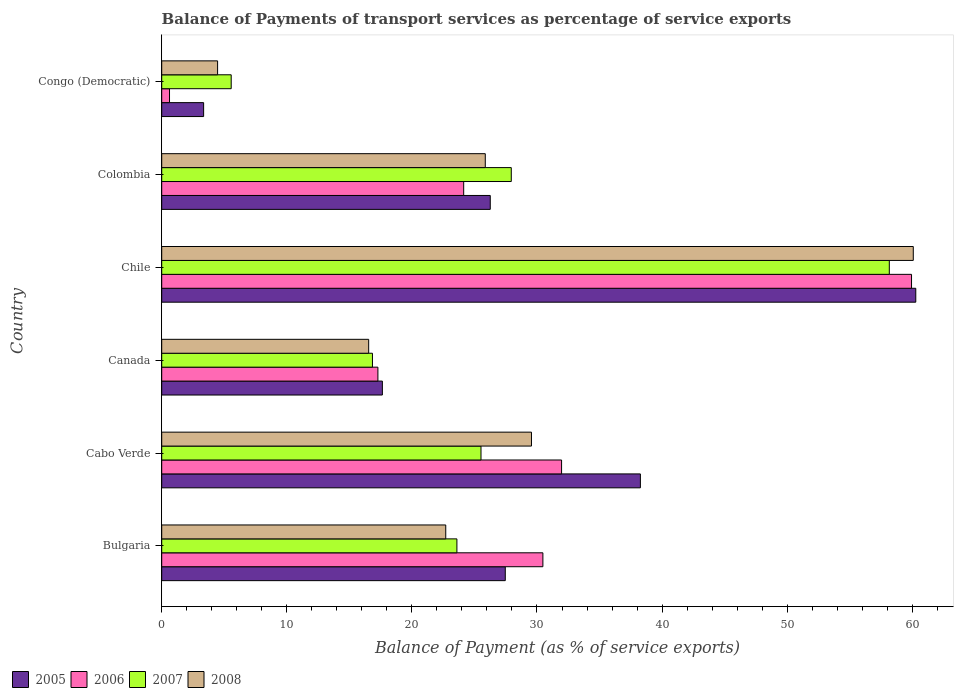How many different coloured bars are there?
Offer a terse response. 4. How many groups of bars are there?
Your answer should be compact. 6. How many bars are there on the 1st tick from the top?
Your answer should be compact. 4. How many bars are there on the 2nd tick from the bottom?
Make the answer very short. 4. What is the label of the 1st group of bars from the top?
Provide a short and direct response. Congo (Democratic). In how many cases, is the number of bars for a given country not equal to the number of legend labels?
Keep it short and to the point. 0. What is the balance of payments of transport services in 2007 in Colombia?
Provide a succinct answer. 27.95. Across all countries, what is the maximum balance of payments of transport services in 2005?
Give a very brief answer. 60.28. Across all countries, what is the minimum balance of payments of transport services in 2006?
Provide a succinct answer. 0.62. In which country was the balance of payments of transport services in 2005 minimum?
Keep it short and to the point. Congo (Democratic). What is the total balance of payments of transport services in 2007 in the graph?
Your response must be concise. 157.64. What is the difference between the balance of payments of transport services in 2006 in Cabo Verde and that in Congo (Democratic)?
Give a very brief answer. 31.34. What is the difference between the balance of payments of transport services in 2006 in Cabo Verde and the balance of payments of transport services in 2008 in Canada?
Provide a succinct answer. 15.42. What is the average balance of payments of transport services in 2008 per country?
Offer a terse response. 26.54. What is the difference between the balance of payments of transport services in 2008 and balance of payments of transport services in 2007 in Congo (Democratic)?
Ensure brevity in your answer.  -1.09. In how many countries, is the balance of payments of transport services in 2005 greater than 6 %?
Provide a short and direct response. 5. What is the ratio of the balance of payments of transport services in 2006 in Bulgaria to that in Canada?
Ensure brevity in your answer.  1.76. Is the difference between the balance of payments of transport services in 2008 in Chile and Colombia greater than the difference between the balance of payments of transport services in 2007 in Chile and Colombia?
Give a very brief answer. Yes. What is the difference between the highest and the second highest balance of payments of transport services in 2006?
Provide a short and direct response. 27.98. What is the difference between the highest and the lowest balance of payments of transport services in 2008?
Keep it short and to the point. 55.62. In how many countries, is the balance of payments of transport services in 2006 greater than the average balance of payments of transport services in 2006 taken over all countries?
Ensure brevity in your answer.  3. Is it the case that in every country, the sum of the balance of payments of transport services in 2006 and balance of payments of transport services in 2008 is greater than the sum of balance of payments of transport services in 2005 and balance of payments of transport services in 2007?
Give a very brief answer. No. What does the 4th bar from the bottom in Colombia represents?
Keep it short and to the point. 2008. How many bars are there?
Offer a terse response. 24. How many countries are there in the graph?
Ensure brevity in your answer.  6. Are the values on the major ticks of X-axis written in scientific E-notation?
Make the answer very short. No. Does the graph contain grids?
Provide a short and direct response. No. Where does the legend appear in the graph?
Your answer should be compact. Bottom left. How are the legend labels stacked?
Provide a succinct answer. Horizontal. What is the title of the graph?
Offer a terse response. Balance of Payments of transport services as percentage of service exports. Does "2000" appear as one of the legend labels in the graph?
Keep it short and to the point. No. What is the label or title of the X-axis?
Provide a short and direct response. Balance of Payment (as % of service exports). What is the label or title of the Y-axis?
Your answer should be very brief. Country. What is the Balance of Payment (as % of service exports) of 2005 in Bulgaria?
Ensure brevity in your answer.  27.47. What is the Balance of Payment (as % of service exports) in 2006 in Bulgaria?
Provide a succinct answer. 30.47. What is the Balance of Payment (as % of service exports) in 2007 in Bulgaria?
Provide a succinct answer. 23.6. What is the Balance of Payment (as % of service exports) of 2008 in Bulgaria?
Your answer should be compact. 22.71. What is the Balance of Payment (as % of service exports) in 2005 in Cabo Verde?
Make the answer very short. 38.27. What is the Balance of Payment (as % of service exports) in 2006 in Cabo Verde?
Offer a terse response. 31.97. What is the Balance of Payment (as % of service exports) of 2007 in Cabo Verde?
Make the answer very short. 25.53. What is the Balance of Payment (as % of service exports) of 2008 in Cabo Verde?
Give a very brief answer. 29.56. What is the Balance of Payment (as % of service exports) of 2005 in Canada?
Provide a succinct answer. 17.64. What is the Balance of Payment (as % of service exports) in 2006 in Canada?
Give a very brief answer. 17.28. What is the Balance of Payment (as % of service exports) in 2007 in Canada?
Offer a terse response. 16.85. What is the Balance of Payment (as % of service exports) in 2008 in Canada?
Give a very brief answer. 16.55. What is the Balance of Payment (as % of service exports) of 2005 in Chile?
Offer a terse response. 60.28. What is the Balance of Payment (as % of service exports) in 2006 in Chile?
Make the answer very short. 59.94. What is the Balance of Payment (as % of service exports) in 2007 in Chile?
Make the answer very short. 58.17. What is the Balance of Payment (as % of service exports) in 2008 in Chile?
Your answer should be very brief. 60.08. What is the Balance of Payment (as % of service exports) in 2005 in Colombia?
Provide a short and direct response. 26.27. What is the Balance of Payment (as % of service exports) in 2006 in Colombia?
Give a very brief answer. 24.14. What is the Balance of Payment (as % of service exports) of 2007 in Colombia?
Ensure brevity in your answer.  27.95. What is the Balance of Payment (as % of service exports) of 2008 in Colombia?
Your answer should be compact. 25.87. What is the Balance of Payment (as % of service exports) of 2005 in Congo (Democratic)?
Offer a terse response. 3.35. What is the Balance of Payment (as % of service exports) of 2006 in Congo (Democratic)?
Give a very brief answer. 0.62. What is the Balance of Payment (as % of service exports) in 2007 in Congo (Democratic)?
Give a very brief answer. 5.56. What is the Balance of Payment (as % of service exports) of 2008 in Congo (Democratic)?
Make the answer very short. 4.47. Across all countries, what is the maximum Balance of Payment (as % of service exports) in 2005?
Your response must be concise. 60.28. Across all countries, what is the maximum Balance of Payment (as % of service exports) of 2006?
Offer a terse response. 59.94. Across all countries, what is the maximum Balance of Payment (as % of service exports) of 2007?
Your answer should be compact. 58.17. Across all countries, what is the maximum Balance of Payment (as % of service exports) of 2008?
Your answer should be very brief. 60.08. Across all countries, what is the minimum Balance of Payment (as % of service exports) in 2005?
Keep it short and to the point. 3.35. Across all countries, what is the minimum Balance of Payment (as % of service exports) of 2006?
Give a very brief answer. 0.62. Across all countries, what is the minimum Balance of Payment (as % of service exports) in 2007?
Provide a succinct answer. 5.56. Across all countries, what is the minimum Balance of Payment (as % of service exports) of 2008?
Make the answer very short. 4.47. What is the total Balance of Payment (as % of service exports) in 2005 in the graph?
Ensure brevity in your answer.  173.27. What is the total Balance of Payment (as % of service exports) of 2006 in the graph?
Your answer should be compact. 164.43. What is the total Balance of Payment (as % of service exports) in 2007 in the graph?
Your answer should be compact. 157.64. What is the total Balance of Payment (as % of service exports) in 2008 in the graph?
Your answer should be compact. 159.23. What is the difference between the Balance of Payment (as % of service exports) in 2005 in Bulgaria and that in Cabo Verde?
Your answer should be compact. -10.8. What is the difference between the Balance of Payment (as % of service exports) in 2006 in Bulgaria and that in Cabo Verde?
Provide a short and direct response. -1.49. What is the difference between the Balance of Payment (as % of service exports) of 2007 in Bulgaria and that in Cabo Verde?
Your answer should be compact. -1.93. What is the difference between the Balance of Payment (as % of service exports) in 2008 in Bulgaria and that in Cabo Verde?
Your response must be concise. -6.85. What is the difference between the Balance of Payment (as % of service exports) in 2005 in Bulgaria and that in Canada?
Ensure brevity in your answer.  9.83. What is the difference between the Balance of Payment (as % of service exports) in 2006 in Bulgaria and that in Canada?
Provide a short and direct response. 13.19. What is the difference between the Balance of Payment (as % of service exports) in 2007 in Bulgaria and that in Canada?
Give a very brief answer. 6.75. What is the difference between the Balance of Payment (as % of service exports) of 2008 in Bulgaria and that in Canada?
Your response must be concise. 6.16. What is the difference between the Balance of Payment (as % of service exports) of 2005 in Bulgaria and that in Chile?
Offer a terse response. -32.82. What is the difference between the Balance of Payment (as % of service exports) in 2006 in Bulgaria and that in Chile?
Your response must be concise. -29.47. What is the difference between the Balance of Payment (as % of service exports) in 2007 in Bulgaria and that in Chile?
Offer a terse response. -34.57. What is the difference between the Balance of Payment (as % of service exports) in 2008 in Bulgaria and that in Chile?
Your response must be concise. -37.38. What is the difference between the Balance of Payment (as % of service exports) in 2005 in Bulgaria and that in Colombia?
Your answer should be very brief. 1.2. What is the difference between the Balance of Payment (as % of service exports) of 2006 in Bulgaria and that in Colombia?
Your response must be concise. 6.33. What is the difference between the Balance of Payment (as % of service exports) in 2007 in Bulgaria and that in Colombia?
Your answer should be very brief. -4.35. What is the difference between the Balance of Payment (as % of service exports) in 2008 in Bulgaria and that in Colombia?
Offer a terse response. -3.16. What is the difference between the Balance of Payment (as % of service exports) in 2005 in Bulgaria and that in Congo (Democratic)?
Your response must be concise. 24.12. What is the difference between the Balance of Payment (as % of service exports) in 2006 in Bulgaria and that in Congo (Democratic)?
Your answer should be compact. 29.85. What is the difference between the Balance of Payment (as % of service exports) of 2007 in Bulgaria and that in Congo (Democratic)?
Ensure brevity in your answer.  18.04. What is the difference between the Balance of Payment (as % of service exports) in 2008 in Bulgaria and that in Congo (Democratic)?
Give a very brief answer. 18.24. What is the difference between the Balance of Payment (as % of service exports) in 2005 in Cabo Verde and that in Canada?
Keep it short and to the point. 20.63. What is the difference between the Balance of Payment (as % of service exports) of 2006 in Cabo Verde and that in Canada?
Keep it short and to the point. 14.68. What is the difference between the Balance of Payment (as % of service exports) of 2007 in Cabo Verde and that in Canada?
Keep it short and to the point. 8.68. What is the difference between the Balance of Payment (as % of service exports) of 2008 in Cabo Verde and that in Canada?
Provide a short and direct response. 13.01. What is the difference between the Balance of Payment (as % of service exports) of 2005 in Cabo Verde and that in Chile?
Provide a succinct answer. -22.02. What is the difference between the Balance of Payment (as % of service exports) of 2006 in Cabo Verde and that in Chile?
Give a very brief answer. -27.98. What is the difference between the Balance of Payment (as % of service exports) of 2007 in Cabo Verde and that in Chile?
Your answer should be compact. -32.64. What is the difference between the Balance of Payment (as % of service exports) in 2008 in Cabo Verde and that in Chile?
Offer a terse response. -30.52. What is the difference between the Balance of Payment (as % of service exports) in 2005 in Cabo Verde and that in Colombia?
Ensure brevity in your answer.  12. What is the difference between the Balance of Payment (as % of service exports) in 2006 in Cabo Verde and that in Colombia?
Give a very brief answer. 7.82. What is the difference between the Balance of Payment (as % of service exports) of 2007 in Cabo Verde and that in Colombia?
Your answer should be compact. -2.42. What is the difference between the Balance of Payment (as % of service exports) of 2008 in Cabo Verde and that in Colombia?
Provide a succinct answer. 3.69. What is the difference between the Balance of Payment (as % of service exports) of 2005 in Cabo Verde and that in Congo (Democratic)?
Provide a short and direct response. 34.92. What is the difference between the Balance of Payment (as % of service exports) of 2006 in Cabo Verde and that in Congo (Democratic)?
Your response must be concise. 31.34. What is the difference between the Balance of Payment (as % of service exports) in 2007 in Cabo Verde and that in Congo (Democratic)?
Provide a succinct answer. 19.97. What is the difference between the Balance of Payment (as % of service exports) in 2008 in Cabo Verde and that in Congo (Democratic)?
Your response must be concise. 25.09. What is the difference between the Balance of Payment (as % of service exports) in 2005 in Canada and that in Chile?
Provide a short and direct response. -42.64. What is the difference between the Balance of Payment (as % of service exports) of 2006 in Canada and that in Chile?
Provide a succinct answer. -42.66. What is the difference between the Balance of Payment (as % of service exports) in 2007 in Canada and that in Chile?
Offer a very short reply. -41.32. What is the difference between the Balance of Payment (as % of service exports) of 2008 in Canada and that in Chile?
Offer a very short reply. -43.54. What is the difference between the Balance of Payment (as % of service exports) of 2005 in Canada and that in Colombia?
Your answer should be compact. -8.63. What is the difference between the Balance of Payment (as % of service exports) of 2006 in Canada and that in Colombia?
Keep it short and to the point. -6.86. What is the difference between the Balance of Payment (as % of service exports) in 2007 in Canada and that in Colombia?
Offer a terse response. -11.1. What is the difference between the Balance of Payment (as % of service exports) of 2008 in Canada and that in Colombia?
Your response must be concise. -9.32. What is the difference between the Balance of Payment (as % of service exports) in 2005 in Canada and that in Congo (Democratic)?
Keep it short and to the point. 14.29. What is the difference between the Balance of Payment (as % of service exports) in 2006 in Canada and that in Congo (Democratic)?
Offer a terse response. 16.66. What is the difference between the Balance of Payment (as % of service exports) in 2007 in Canada and that in Congo (Democratic)?
Ensure brevity in your answer.  11.29. What is the difference between the Balance of Payment (as % of service exports) of 2008 in Canada and that in Congo (Democratic)?
Give a very brief answer. 12.08. What is the difference between the Balance of Payment (as % of service exports) in 2005 in Chile and that in Colombia?
Offer a terse response. 34.02. What is the difference between the Balance of Payment (as % of service exports) of 2006 in Chile and that in Colombia?
Make the answer very short. 35.8. What is the difference between the Balance of Payment (as % of service exports) in 2007 in Chile and that in Colombia?
Offer a very short reply. 30.22. What is the difference between the Balance of Payment (as % of service exports) in 2008 in Chile and that in Colombia?
Give a very brief answer. 34.22. What is the difference between the Balance of Payment (as % of service exports) of 2005 in Chile and that in Congo (Democratic)?
Your answer should be very brief. 56.93. What is the difference between the Balance of Payment (as % of service exports) in 2006 in Chile and that in Congo (Democratic)?
Make the answer very short. 59.32. What is the difference between the Balance of Payment (as % of service exports) of 2007 in Chile and that in Congo (Democratic)?
Give a very brief answer. 52.61. What is the difference between the Balance of Payment (as % of service exports) in 2008 in Chile and that in Congo (Democratic)?
Offer a very short reply. 55.62. What is the difference between the Balance of Payment (as % of service exports) in 2005 in Colombia and that in Congo (Democratic)?
Your answer should be very brief. 22.91. What is the difference between the Balance of Payment (as % of service exports) in 2006 in Colombia and that in Congo (Democratic)?
Keep it short and to the point. 23.52. What is the difference between the Balance of Payment (as % of service exports) of 2007 in Colombia and that in Congo (Democratic)?
Offer a terse response. 22.39. What is the difference between the Balance of Payment (as % of service exports) of 2008 in Colombia and that in Congo (Democratic)?
Keep it short and to the point. 21.4. What is the difference between the Balance of Payment (as % of service exports) of 2005 in Bulgaria and the Balance of Payment (as % of service exports) of 2006 in Cabo Verde?
Provide a short and direct response. -4.5. What is the difference between the Balance of Payment (as % of service exports) of 2005 in Bulgaria and the Balance of Payment (as % of service exports) of 2007 in Cabo Verde?
Your response must be concise. 1.94. What is the difference between the Balance of Payment (as % of service exports) in 2005 in Bulgaria and the Balance of Payment (as % of service exports) in 2008 in Cabo Verde?
Your answer should be compact. -2.09. What is the difference between the Balance of Payment (as % of service exports) in 2006 in Bulgaria and the Balance of Payment (as % of service exports) in 2007 in Cabo Verde?
Your response must be concise. 4.95. What is the difference between the Balance of Payment (as % of service exports) of 2006 in Bulgaria and the Balance of Payment (as % of service exports) of 2008 in Cabo Verde?
Keep it short and to the point. 0.91. What is the difference between the Balance of Payment (as % of service exports) of 2007 in Bulgaria and the Balance of Payment (as % of service exports) of 2008 in Cabo Verde?
Provide a short and direct response. -5.96. What is the difference between the Balance of Payment (as % of service exports) in 2005 in Bulgaria and the Balance of Payment (as % of service exports) in 2006 in Canada?
Your response must be concise. 10.18. What is the difference between the Balance of Payment (as % of service exports) in 2005 in Bulgaria and the Balance of Payment (as % of service exports) in 2007 in Canada?
Your answer should be compact. 10.62. What is the difference between the Balance of Payment (as % of service exports) of 2005 in Bulgaria and the Balance of Payment (as % of service exports) of 2008 in Canada?
Make the answer very short. 10.92. What is the difference between the Balance of Payment (as % of service exports) in 2006 in Bulgaria and the Balance of Payment (as % of service exports) in 2007 in Canada?
Your response must be concise. 13.63. What is the difference between the Balance of Payment (as % of service exports) in 2006 in Bulgaria and the Balance of Payment (as % of service exports) in 2008 in Canada?
Offer a very short reply. 13.93. What is the difference between the Balance of Payment (as % of service exports) in 2007 in Bulgaria and the Balance of Payment (as % of service exports) in 2008 in Canada?
Your answer should be very brief. 7.05. What is the difference between the Balance of Payment (as % of service exports) of 2005 in Bulgaria and the Balance of Payment (as % of service exports) of 2006 in Chile?
Provide a short and direct response. -32.48. What is the difference between the Balance of Payment (as % of service exports) in 2005 in Bulgaria and the Balance of Payment (as % of service exports) in 2007 in Chile?
Offer a very short reply. -30.7. What is the difference between the Balance of Payment (as % of service exports) of 2005 in Bulgaria and the Balance of Payment (as % of service exports) of 2008 in Chile?
Your answer should be compact. -32.62. What is the difference between the Balance of Payment (as % of service exports) in 2006 in Bulgaria and the Balance of Payment (as % of service exports) in 2007 in Chile?
Make the answer very short. -27.69. What is the difference between the Balance of Payment (as % of service exports) of 2006 in Bulgaria and the Balance of Payment (as % of service exports) of 2008 in Chile?
Keep it short and to the point. -29.61. What is the difference between the Balance of Payment (as % of service exports) in 2007 in Bulgaria and the Balance of Payment (as % of service exports) in 2008 in Chile?
Your answer should be very brief. -36.48. What is the difference between the Balance of Payment (as % of service exports) of 2005 in Bulgaria and the Balance of Payment (as % of service exports) of 2006 in Colombia?
Keep it short and to the point. 3.33. What is the difference between the Balance of Payment (as % of service exports) of 2005 in Bulgaria and the Balance of Payment (as % of service exports) of 2007 in Colombia?
Offer a terse response. -0.48. What is the difference between the Balance of Payment (as % of service exports) in 2005 in Bulgaria and the Balance of Payment (as % of service exports) in 2008 in Colombia?
Your response must be concise. 1.6. What is the difference between the Balance of Payment (as % of service exports) in 2006 in Bulgaria and the Balance of Payment (as % of service exports) in 2007 in Colombia?
Make the answer very short. 2.53. What is the difference between the Balance of Payment (as % of service exports) of 2006 in Bulgaria and the Balance of Payment (as % of service exports) of 2008 in Colombia?
Your response must be concise. 4.61. What is the difference between the Balance of Payment (as % of service exports) of 2007 in Bulgaria and the Balance of Payment (as % of service exports) of 2008 in Colombia?
Offer a terse response. -2.27. What is the difference between the Balance of Payment (as % of service exports) in 2005 in Bulgaria and the Balance of Payment (as % of service exports) in 2006 in Congo (Democratic)?
Keep it short and to the point. 26.84. What is the difference between the Balance of Payment (as % of service exports) in 2005 in Bulgaria and the Balance of Payment (as % of service exports) in 2007 in Congo (Democratic)?
Your response must be concise. 21.91. What is the difference between the Balance of Payment (as % of service exports) in 2005 in Bulgaria and the Balance of Payment (as % of service exports) in 2008 in Congo (Democratic)?
Make the answer very short. 23. What is the difference between the Balance of Payment (as % of service exports) of 2006 in Bulgaria and the Balance of Payment (as % of service exports) of 2007 in Congo (Democratic)?
Give a very brief answer. 24.92. What is the difference between the Balance of Payment (as % of service exports) of 2006 in Bulgaria and the Balance of Payment (as % of service exports) of 2008 in Congo (Democratic)?
Ensure brevity in your answer.  26.01. What is the difference between the Balance of Payment (as % of service exports) in 2007 in Bulgaria and the Balance of Payment (as % of service exports) in 2008 in Congo (Democratic)?
Provide a succinct answer. 19.13. What is the difference between the Balance of Payment (as % of service exports) of 2005 in Cabo Verde and the Balance of Payment (as % of service exports) of 2006 in Canada?
Offer a very short reply. 20.98. What is the difference between the Balance of Payment (as % of service exports) in 2005 in Cabo Verde and the Balance of Payment (as % of service exports) in 2007 in Canada?
Ensure brevity in your answer.  21.42. What is the difference between the Balance of Payment (as % of service exports) of 2005 in Cabo Verde and the Balance of Payment (as % of service exports) of 2008 in Canada?
Make the answer very short. 21.72. What is the difference between the Balance of Payment (as % of service exports) in 2006 in Cabo Verde and the Balance of Payment (as % of service exports) in 2007 in Canada?
Keep it short and to the point. 15.12. What is the difference between the Balance of Payment (as % of service exports) of 2006 in Cabo Verde and the Balance of Payment (as % of service exports) of 2008 in Canada?
Your response must be concise. 15.42. What is the difference between the Balance of Payment (as % of service exports) in 2007 in Cabo Verde and the Balance of Payment (as % of service exports) in 2008 in Canada?
Give a very brief answer. 8.98. What is the difference between the Balance of Payment (as % of service exports) in 2005 in Cabo Verde and the Balance of Payment (as % of service exports) in 2006 in Chile?
Make the answer very short. -21.68. What is the difference between the Balance of Payment (as % of service exports) in 2005 in Cabo Verde and the Balance of Payment (as % of service exports) in 2007 in Chile?
Make the answer very short. -19.9. What is the difference between the Balance of Payment (as % of service exports) in 2005 in Cabo Verde and the Balance of Payment (as % of service exports) in 2008 in Chile?
Provide a succinct answer. -21.82. What is the difference between the Balance of Payment (as % of service exports) in 2006 in Cabo Verde and the Balance of Payment (as % of service exports) in 2007 in Chile?
Your answer should be compact. -26.2. What is the difference between the Balance of Payment (as % of service exports) of 2006 in Cabo Verde and the Balance of Payment (as % of service exports) of 2008 in Chile?
Give a very brief answer. -28.12. What is the difference between the Balance of Payment (as % of service exports) of 2007 in Cabo Verde and the Balance of Payment (as % of service exports) of 2008 in Chile?
Provide a short and direct response. -34.56. What is the difference between the Balance of Payment (as % of service exports) of 2005 in Cabo Verde and the Balance of Payment (as % of service exports) of 2006 in Colombia?
Provide a short and direct response. 14.13. What is the difference between the Balance of Payment (as % of service exports) in 2005 in Cabo Verde and the Balance of Payment (as % of service exports) in 2007 in Colombia?
Your response must be concise. 10.32. What is the difference between the Balance of Payment (as % of service exports) of 2005 in Cabo Verde and the Balance of Payment (as % of service exports) of 2008 in Colombia?
Offer a very short reply. 12.4. What is the difference between the Balance of Payment (as % of service exports) in 2006 in Cabo Verde and the Balance of Payment (as % of service exports) in 2007 in Colombia?
Provide a succinct answer. 4.02. What is the difference between the Balance of Payment (as % of service exports) of 2006 in Cabo Verde and the Balance of Payment (as % of service exports) of 2008 in Colombia?
Keep it short and to the point. 6.1. What is the difference between the Balance of Payment (as % of service exports) in 2007 in Cabo Verde and the Balance of Payment (as % of service exports) in 2008 in Colombia?
Your answer should be very brief. -0.34. What is the difference between the Balance of Payment (as % of service exports) of 2005 in Cabo Verde and the Balance of Payment (as % of service exports) of 2006 in Congo (Democratic)?
Keep it short and to the point. 37.64. What is the difference between the Balance of Payment (as % of service exports) of 2005 in Cabo Verde and the Balance of Payment (as % of service exports) of 2007 in Congo (Democratic)?
Your answer should be very brief. 32.71. What is the difference between the Balance of Payment (as % of service exports) in 2005 in Cabo Verde and the Balance of Payment (as % of service exports) in 2008 in Congo (Democratic)?
Ensure brevity in your answer.  33.8. What is the difference between the Balance of Payment (as % of service exports) of 2006 in Cabo Verde and the Balance of Payment (as % of service exports) of 2007 in Congo (Democratic)?
Your answer should be compact. 26.41. What is the difference between the Balance of Payment (as % of service exports) of 2006 in Cabo Verde and the Balance of Payment (as % of service exports) of 2008 in Congo (Democratic)?
Offer a terse response. 27.5. What is the difference between the Balance of Payment (as % of service exports) of 2007 in Cabo Verde and the Balance of Payment (as % of service exports) of 2008 in Congo (Democratic)?
Ensure brevity in your answer.  21.06. What is the difference between the Balance of Payment (as % of service exports) in 2005 in Canada and the Balance of Payment (as % of service exports) in 2006 in Chile?
Give a very brief answer. -42.3. What is the difference between the Balance of Payment (as % of service exports) of 2005 in Canada and the Balance of Payment (as % of service exports) of 2007 in Chile?
Make the answer very short. -40.53. What is the difference between the Balance of Payment (as % of service exports) of 2005 in Canada and the Balance of Payment (as % of service exports) of 2008 in Chile?
Keep it short and to the point. -42.44. What is the difference between the Balance of Payment (as % of service exports) in 2006 in Canada and the Balance of Payment (as % of service exports) in 2007 in Chile?
Offer a very short reply. -40.88. What is the difference between the Balance of Payment (as % of service exports) in 2006 in Canada and the Balance of Payment (as % of service exports) in 2008 in Chile?
Offer a terse response. -42.8. What is the difference between the Balance of Payment (as % of service exports) of 2007 in Canada and the Balance of Payment (as % of service exports) of 2008 in Chile?
Offer a terse response. -43.24. What is the difference between the Balance of Payment (as % of service exports) of 2005 in Canada and the Balance of Payment (as % of service exports) of 2006 in Colombia?
Ensure brevity in your answer.  -6.5. What is the difference between the Balance of Payment (as % of service exports) of 2005 in Canada and the Balance of Payment (as % of service exports) of 2007 in Colombia?
Ensure brevity in your answer.  -10.31. What is the difference between the Balance of Payment (as % of service exports) in 2005 in Canada and the Balance of Payment (as % of service exports) in 2008 in Colombia?
Offer a very short reply. -8.23. What is the difference between the Balance of Payment (as % of service exports) in 2006 in Canada and the Balance of Payment (as % of service exports) in 2007 in Colombia?
Your response must be concise. -10.66. What is the difference between the Balance of Payment (as % of service exports) in 2006 in Canada and the Balance of Payment (as % of service exports) in 2008 in Colombia?
Make the answer very short. -8.58. What is the difference between the Balance of Payment (as % of service exports) in 2007 in Canada and the Balance of Payment (as % of service exports) in 2008 in Colombia?
Provide a succinct answer. -9.02. What is the difference between the Balance of Payment (as % of service exports) in 2005 in Canada and the Balance of Payment (as % of service exports) in 2006 in Congo (Democratic)?
Your response must be concise. 17.02. What is the difference between the Balance of Payment (as % of service exports) in 2005 in Canada and the Balance of Payment (as % of service exports) in 2007 in Congo (Democratic)?
Offer a very short reply. 12.08. What is the difference between the Balance of Payment (as % of service exports) of 2005 in Canada and the Balance of Payment (as % of service exports) of 2008 in Congo (Democratic)?
Offer a very short reply. 13.17. What is the difference between the Balance of Payment (as % of service exports) in 2006 in Canada and the Balance of Payment (as % of service exports) in 2007 in Congo (Democratic)?
Give a very brief answer. 11.73. What is the difference between the Balance of Payment (as % of service exports) of 2006 in Canada and the Balance of Payment (as % of service exports) of 2008 in Congo (Democratic)?
Give a very brief answer. 12.82. What is the difference between the Balance of Payment (as % of service exports) in 2007 in Canada and the Balance of Payment (as % of service exports) in 2008 in Congo (Democratic)?
Offer a very short reply. 12.38. What is the difference between the Balance of Payment (as % of service exports) of 2005 in Chile and the Balance of Payment (as % of service exports) of 2006 in Colombia?
Give a very brief answer. 36.14. What is the difference between the Balance of Payment (as % of service exports) in 2005 in Chile and the Balance of Payment (as % of service exports) in 2007 in Colombia?
Ensure brevity in your answer.  32.34. What is the difference between the Balance of Payment (as % of service exports) of 2005 in Chile and the Balance of Payment (as % of service exports) of 2008 in Colombia?
Your answer should be very brief. 34.42. What is the difference between the Balance of Payment (as % of service exports) in 2006 in Chile and the Balance of Payment (as % of service exports) in 2007 in Colombia?
Keep it short and to the point. 32. What is the difference between the Balance of Payment (as % of service exports) in 2006 in Chile and the Balance of Payment (as % of service exports) in 2008 in Colombia?
Provide a succinct answer. 34.08. What is the difference between the Balance of Payment (as % of service exports) in 2007 in Chile and the Balance of Payment (as % of service exports) in 2008 in Colombia?
Provide a succinct answer. 32.3. What is the difference between the Balance of Payment (as % of service exports) in 2005 in Chile and the Balance of Payment (as % of service exports) in 2006 in Congo (Democratic)?
Keep it short and to the point. 59.66. What is the difference between the Balance of Payment (as % of service exports) of 2005 in Chile and the Balance of Payment (as % of service exports) of 2007 in Congo (Democratic)?
Provide a succinct answer. 54.73. What is the difference between the Balance of Payment (as % of service exports) of 2005 in Chile and the Balance of Payment (as % of service exports) of 2008 in Congo (Democratic)?
Offer a very short reply. 55.82. What is the difference between the Balance of Payment (as % of service exports) of 2006 in Chile and the Balance of Payment (as % of service exports) of 2007 in Congo (Democratic)?
Your answer should be compact. 54.39. What is the difference between the Balance of Payment (as % of service exports) of 2006 in Chile and the Balance of Payment (as % of service exports) of 2008 in Congo (Democratic)?
Make the answer very short. 55.48. What is the difference between the Balance of Payment (as % of service exports) of 2007 in Chile and the Balance of Payment (as % of service exports) of 2008 in Congo (Democratic)?
Provide a short and direct response. 53.7. What is the difference between the Balance of Payment (as % of service exports) in 2005 in Colombia and the Balance of Payment (as % of service exports) in 2006 in Congo (Democratic)?
Make the answer very short. 25.64. What is the difference between the Balance of Payment (as % of service exports) in 2005 in Colombia and the Balance of Payment (as % of service exports) in 2007 in Congo (Democratic)?
Give a very brief answer. 20.71. What is the difference between the Balance of Payment (as % of service exports) of 2005 in Colombia and the Balance of Payment (as % of service exports) of 2008 in Congo (Democratic)?
Give a very brief answer. 21.8. What is the difference between the Balance of Payment (as % of service exports) of 2006 in Colombia and the Balance of Payment (as % of service exports) of 2007 in Congo (Democratic)?
Provide a succinct answer. 18.59. What is the difference between the Balance of Payment (as % of service exports) of 2006 in Colombia and the Balance of Payment (as % of service exports) of 2008 in Congo (Democratic)?
Provide a short and direct response. 19.67. What is the difference between the Balance of Payment (as % of service exports) of 2007 in Colombia and the Balance of Payment (as % of service exports) of 2008 in Congo (Democratic)?
Your response must be concise. 23.48. What is the average Balance of Payment (as % of service exports) of 2005 per country?
Ensure brevity in your answer.  28.88. What is the average Balance of Payment (as % of service exports) of 2006 per country?
Your response must be concise. 27.41. What is the average Balance of Payment (as % of service exports) of 2007 per country?
Ensure brevity in your answer.  26.27. What is the average Balance of Payment (as % of service exports) of 2008 per country?
Ensure brevity in your answer.  26.54. What is the difference between the Balance of Payment (as % of service exports) in 2005 and Balance of Payment (as % of service exports) in 2006 in Bulgaria?
Your answer should be compact. -3.01. What is the difference between the Balance of Payment (as % of service exports) of 2005 and Balance of Payment (as % of service exports) of 2007 in Bulgaria?
Ensure brevity in your answer.  3.87. What is the difference between the Balance of Payment (as % of service exports) of 2005 and Balance of Payment (as % of service exports) of 2008 in Bulgaria?
Provide a succinct answer. 4.76. What is the difference between the Balance of Payment (as % of service exports) of 2006 and Balance of Payment (as % of service exports) of 2007 in Bulgaria?
Make the answer very short. 6.87. What is the difference between the Balance of Payment (as % of service exports) of 2006 and Balance of Payment (as % of service exports) of 2008 in Bulgaria?
Give a very brief answer. 7.77. What is the difference between the Balance of Payment (as % of service exports) in 2007 and Balance of Payment (as % of service exports) in 2008 in Bulgaria?
Provide a short and direct response. 0.89. What is the difference between the Balance of Payment (as % of service exports) of 2005 and Balance of Payment (as % of service exports) of 2006 in Cabo Verde?
Make the answer very short. 6.3. What is the difference between the Balance of Payment (as % of service exports) of 2005 and Balance of Payment (as % of service exports) of 2007 in Cabo Verde?
Your answer should be very brief. 12.74. What is the difference between the Balance of Payment (as % of service exports) of 2005 and Balance of Payment (as % of service exports) of 2008 in Cabo Verde?
Provide a succinct answer. 8.71. What is the difference between the Balance of Payment (as % of service exports) in 2006 and Balance of Payment (as % of service exports) in 2007 in Cabo Verde?
Your response must be concise. 6.44. What is the difference between the Balance of Payment (as % of service exports) of 2006 and Balance of Payment (as % of service exports) of 2008 in Cabo Verde?
Your answer should be very brief. 2.41. What is the difference between the Balance of Payment (as % of service exports) of 2007 and Balance of Payment (as % of service exports) of 2008 in Cabo Verde?
Your answer should be very brief. -4.03. What is the difference between the Balance of Payment (as % of service exports) in 2005 and Balance of Payment (as % of service exports) in 2006 in Canada?
Offer a terse response. 0.36. What is the difference between the Balance of Payment (as % of service exports) in 2005 and Balance of Payment (as % of service exports) in 2007 in Canada?
Offer a very short reply. 0.79. What is the difference between the Balance of Payment (as % of service exports) of 2005 and Balance of Payment (as % of service exports) of 2008 in Canada?
Your answer should be very brief. 1.09. What is the difference between the Balance of Payment (as % of service exports) of 2006 and Balance of Payment (as % of service exports) of 2007 in Canada?
Offer a terse response. 0.44. What is the difference between the Balance of Payment (as % of service exports) of 2006 and Balance of Payment (as % of service exports) of 2008 in Canada?
Make the answer very short. 0.74. What is the difference between the Balance of Payment (as % of service exports) of 2007 and Balance of Payment (as % of service exports) of 2008 in Canada?
Your answer should be very brief. 0.3. What is the difference between the Balance of Payment (as % of service exports) of 2005 and Balance of Payment (as % of service exports) of 2006 in Chile?
Give a very brief answer. 0.34. What is the difference between the Balance of Payment (as % of service exports) in 2005 and Balance of Payment (as % of service exports) in 2007 in Chile?
Your response must be concise. 2.12. What is the difference between the Balance of Payment (as % of service exports) in 2005 and Balance of Payment (as % of service exports) in 2008 in Chile?
Ensure brevity in your answer.  0.2. What is the difference between the Balance of Payment (as % of service exports) in 2006 and Balance of Payment (as % of service exports) in 2007 in Chile?
Make the answer very short. 1.78. What is the difference between the Balance of Payment (as % of service exports) of 2006 and Balance of Payment (as % of service exports) of 2008 in Chile?
Your answer should be very brief. -0.14. What is the difference between the Balance of Payment (as % of service exports) of 2007 and Balance of Payment (as % of service exports) of 2008 in Chile?
Your answer should be very brief. -1.92. What is the difference between the Balance of Payment (as % of service exports) of 2005 and Balance of Payment (as % of service exports) of 2006 in Colombia?
Ensure brevity in your answer.  2.12. What is the difference between the Balance of Payment (as % of service exports) of 2005 and Balance of Payment (as % of service exports) of 2007 in Colombia?
Offer a very short reply. -1.68. What is the difference between the Balance of Payment (as % of service exports) of 2005 and Balance of Payment (as % of service exports) of 2008 in Colombia?
Offer a terse response. 0.4. What is the difference between the Balance of Payment (as % of service exports) in 2006 and Balance of Payment (as % of service exports) in 2007 in Colombia?
Provide a succinct answer. -3.8. What is the difference between the Balance of Payment (as % of service exports) in 2006 and Balance of Payment (as % of service exports) in 2008 in Colombia?
Your answer should be very brief. -1.73. What is the difference between the Balance of Payment (as % of service exports) of 2007 and Balance of Payment (as % of service exports) of 2008 in Colombia?
Offer a terse response. 2.08. What is the difference between the Balance of Payment (as % of service exports) in 2005 and Balance of Payment (as % of service exports) in 2006 in Congo (Democratic)?
Offer a terse response. 2.73. What is the difference between the Balance of Payment (as % of service exports) in 2005 and Balance of Payment (as % of service exports) in 2007 in Congo (Democratic)?
Your answer should be very brief. -2.2. What is the difference between the Balance of Payment (as % of service exports) of 2005 and Balance of Payment (as % of service exports) of 2008 in Congo (Democratic)?
Offer a terse response. -1.12. What is the difference between the Balance of Payment (as % of service exports) of 2006 and Balance of Payment (as % of service exports) of 2007 in Congo (Democratic)?
Your answer should be very brief. -4.93. What is the difference between the Balance of Payment (as % of service exports) of 2006 and Balance of Payment (as % of service exports) of 2008 in Congo (Democratic)?
Your response must be concise. -3.84. What is the difference between the Balance of Payment (as % of service exports) in 2007 and Balance of Payment (as % of service exports) in 2008 in Congo (Democratic)?
Your answer should be very brief. 1.09. What is the ratio of the Balance of Payment (as % of service exports) in 2005 in Bulgaria to that in Cabo Verde?
Keep it short and to the point. 0.72. What is the ratio of the Balance of Payment (as % of service exports) of 2006 in Bulgaria to that in Cabo Verde?
Your response must be concise. 0.95. What is the ratio of the Balance of Payment (as % of service exports) of 2007 in Bulgaria to that in Cabo Verde?
Offer a very short reply. 0.92. What is the ratio of the Balance of Payment (as % of service exports) in 2008 in Bulgaria to that in Cabo Verde?
Ensure brevity in your answer.  0.77. What is the ratio of the Balance of Payment (as % of service exports) in 2005 in Bulgaria to that in Canada?
Provide a short and direct response. 1.56. What is the ratio of the Balance of Payment (as % of service exports) in 2006 in Bulgaria to that in Canada?
Keep it short and to the point. 1.76. What is the ratio of the Balance of Payment (as % of service exports) in 2007 in Bulgaria to that in Canada?
Provide a succinct answer. 1.4. What is the ratio of the Balance of Payment (as % of service exports) in 2008 in Bulgaria to that in Canada?
Offer a terse response. 1.37. What is the ratio of the Balance of Payment (as % of service exports) of 2005 in Bulgaria to that in Chile?
Make the answer very short. 0.46. What is the ratio of the Balance of Payment (as % of service exports) of 2006 in Bulgaria to that in Chile?
Offer a very short reply. 0.51. What is the ratio of the Balance of Payment (as % of service exports) in 2007 in Bulgaria to that in Chile?
Your answer should be compact. 0.41. What is the ratio of the Balance of Payment (as % of service exports) in 2008 in Bulgaria to that in Chile?
Your response must be concise. 0.38. What is the ratio of the Balance of Payment (as % of service exports) in 2005 in Bulgaria to that in Colombia?
Your answer should be very brief. 1.05. What is the ratio of the Balance of Payment (as % of service exports) of 2006 in Bulgaria to that in Colombia?
Provide a short and direct response. 1.26. What is the ratio of the Balance of Payment (as % of service exports) of 2007 in Bulgaria to that in Colombia?
Offer a very short reply. 0.84. What is the ratio of the Balance of Payment (as % of service exports) of 2008 in Bulgaria to that in Colombia?
Provide a short and direct response. 0.88. What is the ratio of the Balance of Payment (as % of service exports) of 2005 in Bulgaria to that in Congo (Democratic)?
Provide a short and direct response. 8.2. What is the ratio of the Balance of Payment (as % of service exports) of 2006 in Bulgaria to that in Congo (Democratic)?
Offer a terse response. 48.86. What is the ratio of the Balance of Payment (as % of service exports) in 2007 in Bulgaria to that in Congo (Democratic)?
Provide a succinct answer. 4.25. What is the ratio of the Balance of Payment (as % of service exports) in 2008 in Bulgaria to that in Congo (Democratic)?
Keep it short and to the point. 5.08. What is the ratio of the Balance of Payment (as % of service exports) in 2005 in Cabo Verde to that in Canada?
Your answer should be very brief. 2.17. What is the ratio of the Balance of Payment (as % of service exports) in 2006 in Cabo Verde to that in Canada?
Your response must be concise. 1.85. What is the ratio of the Balance of Payment (as % of service exports) in 2007 in Cabo Verde to that in Canada?
Keep it short and to the point. 1.52. What is the ratio of the Balance of Payment (as % of service exports) in 2008 in Cabo Verde to that in Canada?
Provide a succinct answer. 1.79. What is the ratio of the Balance of Payment (as % of service exports) of 2005 in Cabo Verde to that in Chile?
Provide a short and direct response. 0.63. What is the ratio of the Balance of Payment (as % of service exports) in 2006 in Cabo Verde to that in Chile?
Give a very brief answer. 0.53. What is the ratio of the Balance of Payment (as % of service exports) of 2007 in Cabo Verde to that in Chile?
Your response must be concise. 0.44. What is the ratio of the Balance of Payment (as % of service exports) of 2008 in Cabo Verde to that in Chile?
Offer a terse response. 0.49. What is the ratio of the Balance of Payment (as % of service exports) of 2005 in Cabo Verde to that in Colombia?
Make the answer very short. 1.46. What is the ratio of the Balance of Payment (as % of service exports) of 2006 in Cabo Verde to that in Colombia?
Give a very brief answer. 1.32. What is the ratio of the Balance of Payment (as % of service exports) in 2007 in Cabo Verde to that in Colombia?
Offer a very short reply. 0.91. What is the ratio of the Balance of Payment (as % of service exports) of 2008 in Cabo Verde to that in Colombia?
Give a very brief answer. 1.14. What is the ratio of the Balance of Payment (as % of service exports) of 2005 in Cabo Verde to that in Congo (Democratic)?
Ensure brevity in your answer.  11.42. What is the ratio of the Balance of Payment (as % of service exports) of 2006 in Cabo Verde to that in Congo (Democratic)?
Your answer should be very brief. 51.25. What is the ratio of the Balance of Payment (as % of service exports) in 2007 in Cabo Verde to that in Congo (Democratic)?
Keep it short and to the point. 4.59. What is the ratio of the Balance of Payment (as % of service exports) of 2008 in Cabo Verde to that in Congo (Democratic)?
Give a very brief answer. 6.62. What is the ratio of the Balance of Payment (as % of service exports) in 2005 in Canada to that in Chile?
Give a very brief answer. 0.29. What is the ratio of the Balance of Payment (as % of service exports) in 2006 in Canada to that in Chile?
Your answer should be very brief. 0.29. What is the ratio of the Balance of Payment (as % of service exports) in 2007 in Canada to that in Chile?
Ensure brevity in your answer.  0.29. What is the ratio of the Balance of Payment (as % of service exports) of 2008 in Canada to that in Chile?
Offer a very short reply. 0.28. What is the ratio of the Balance of Payment (as % of service exports) of 2005 in Canada to that in Colombia?
Provide a short and direct response. 0.67. What is the ratio of the Balance of Payment (as % of service exports) of 2006 in Canada to that in Colombia?
Provide a succinct answer. 0.72. What is the ratio of the Balance of Payment (as % of service exports) in 2007 in Canada to that in Colombia?
Ensure brevity in your answer.  0.6. What is the ratio of the Balance of Payment (as % of service exports) of 2008 in Canada to that in Colombia?
Your answer should be compact. 0.64. What is the ratio of the Balance of Payment (as % of service exports) of 2005 in Canada to that in Congo (Democratic)?
Offer a very short reply. 5.26. What is the ratio of the Balance of Payment (as % of service exports) in 2006 in Canada to that in Congo (Democratic)?
Your answer should be compact. 27.71. What is the ratio of the Balance of Payment (as % of service exports) of 2007 in Canada to that in Congo (Democratic)?
Offer a very short reply. 3.03. What is the ratio of the Balance of Payment (as % of service exports) in 2008 in Canada to that in Congo (Democratic)?
Give a very brief answer. 3.7. What is the ratio of the Balance of Payment (as % of service exports) in 2005 in Chile to that in Colombia?
Give a very brief answer. 2.3. What is the ratio of the Balance of Payment (as % of service exports) of 2006 in Chile to that in Colombia?
Provide a succinct answer. 2.48. What is the ratio of the Balance of Payment (as % of service exports) in 2007 in Chile to that in Colombia?
Offer a terse response. 2.08. What is the ratio of the Balance of Payment (as % of service exports) of 2008 in Chile to that in Colombia?
Provide a short and direct response. 2.32. What is the ratio of the Balance of Payment (as % of service exports) in 2005 in Chile to that in Congo (Democratic)?
Provide a short and direct response. 17.99. What is the ratio of the Balance of Payment (as % of service exports) of 2006 in Chile to that in Congo (Democratic)?
Offer a very short reply. 96.11. What is the ratio of the Balance of Payment (as % of service exports) of 2007 in Chile to that in Congo (Democratic)?
Your answer should be very brief. 10.47. What is the ratio of the Balance of Payment (as % of service exports) in 2008 in Chile to that in Congo (Democratic)?
Your response must be concise. 13.45. What is the ratio of the Balance of Payment (as % of service exports) of 2005 in Colombia to that in Congo (Democratic)?
Make the answer very short. 7.84. What is the ratio of the Balance of Payment (as % of service exports) in 2006 in Colombia to that in Congo (Democratic)?
Your answer should be very brief. 38.71. What is the ratio of the Balance of Payment (as % of service exports) in 2007 in Colombia to that in Congo (Democratic)?
Your response must be concise. 5.03. What is the ratio of the Balance of Payment (as % of service exports) in 2008 in Colombia to that in Congo (Democratic)?
Your answer should be compact. 5.79. What is the difference between the highest and the second highest Balance of Payment (as % of service exports) in 2005?
Your answer should be compact. 22.02. What is the difference between the highest and the second highest Balance of Payment (as % of service exports) of 2006?
Ensure brevity in your answer.  27.98. What is the difference between the highest and the second highest Balance of Payment (as % of service exports) of 2007?
Offer a terse response. 30.22. What is the difference between the highest and the second highest Balance of Payment (as % of service exports) in 2008?
Offer a terse response. 30.52. What is the difference between the highest and the lowest Balance of Payment (as % of service exports) of 2005?
Ensure brevity in your answer.  56.93. What is the difference between the highest and the lowest Balance of Payment (as % of service exports) in 2006?
Ensure brevity in your answer.  59.32. What is the difference between the highest and the lowest Balance of Payment (as % of service exports) in 2007?
Your answer should be very brief. 52.61. What is the difference between the highest and the lowest Balance of Payment (as % of service exports) of 2008?
Make the answer very short. 55.62. 